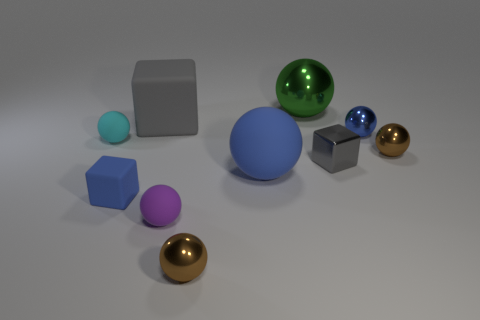Subtract all blue balls. How many balls are left? 5 Subtract all blue cubes. How many cubes are left? 2 Subtract all blocks. How many objects are left? 7 Subtract 6 balls. How many balls are left? 1 Subtract all cyan spheres. Subtract all gray cylinders. How many spheres are left? 6 Subtract all blue balls. How many blue cubes are left? 1 Subtract all big gray objects. Subtract all big spheres. How many objects are left? 7 Add 1 big shiny balls. How many big shiny balls are left? 2 Add 5 tiny metal balls. How many tiny metal balls exist? 8 Subtract 1 cyan spheres. How many objects are left? 9 